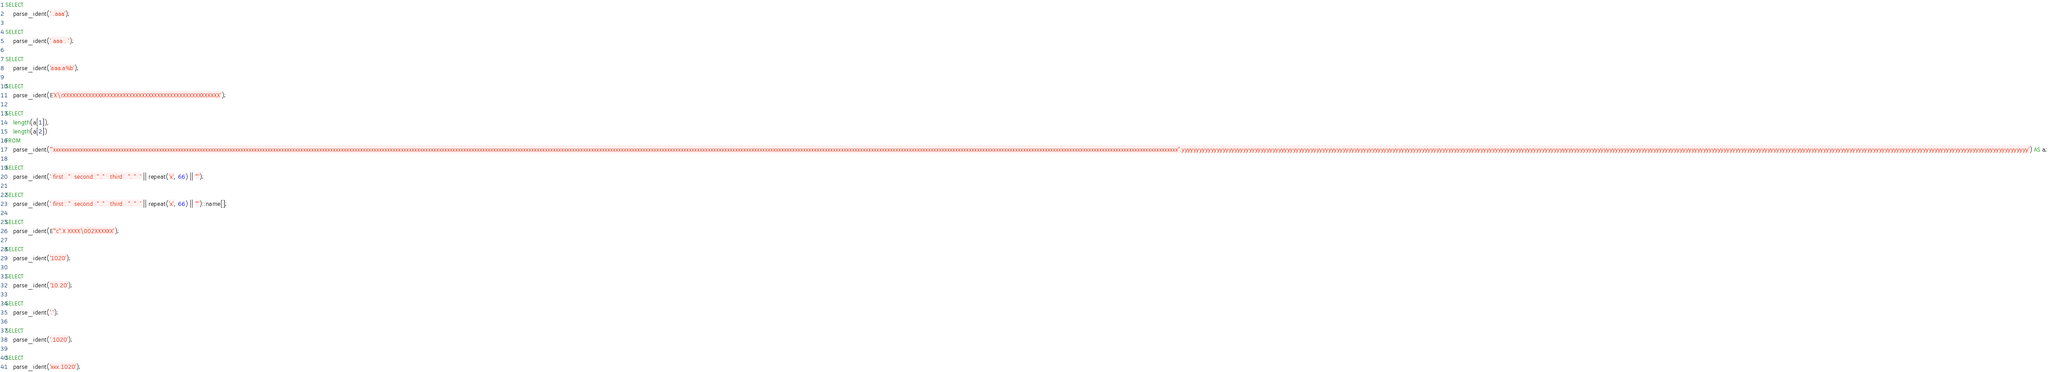<code> <loc_0><loc_0><loc_500><loc_500><_SQL_>SELECT
    parse_ident(' .aaa');

SELECT
    parse_ident(' aaa . ');

SELECT
    parse_ident('aaa.a%b');

SELECT
    parse_ident(E'X\rXXXXXXXXXXXXXXXXXXXXXXXXXXXXXXXXXXXXXXXXXXXXXXXXXX');

SELECT
    length(a[1]),
    length(a[2])
FROM
    parse_ident('"xxxxxxxxxxxxxxxxxxxxxxxxxxxxxxxxxxxxxxxxxxxxxxxxxxxxxxxxxxxxxxxxxxxxxxxxxxxxxxxxxxxxxxxxxxxxxxxxxxxxxxxxxxxxxxxxxxxxxxxxxxxxxxxxxxxxxxxxxxxxxxxxxxxxxxxxxxxxxxxxxxxxxxxxxxxxxxxxxxxxxxxxxxxxxxxxxxxxxxxxxxxxxxxxxxxxxxxxxxxxxxxxxxxxxxxxxxxxxxxxxxxxxxxxxxxxxxxxxxxxxxxxxxxxxxxxxxxxxxxxxxxxxxxxxxxxxxxxxxxxxxxxxxxxxxxxxxxxxxxxxxxxxxxxxxxxxxxxxxxxxxxxxxxxxxxxxxxxxxxxxxxxxxxxxxxxxxxxxxxxxxxxxxxxxxxxxxxxxxxxxxxxxxxxxxxxxx".yyyyyyyyyyyyyyyyyyyyyyyyyyyyyyyyyyyyyyyyyyyyyyyyyyyyyyyyyyyyyyyyyyyyyyyyyyyyyyyyyyyyyyyyyyyyyyyyyyyyyyyyyyyyyyyyyyyyyyyyyyyyyyyyyyyyyyyyyyyyyyyyyyyyyyyyyyyyyyyyyyyyyyyyyyyyyyyyyyyyyyyyyyyyyyyyyyyyyyyyyyyyyyyyyyyyyyyyyyyyyyyyyyyyyyyyyyyyyyyyyyyyyyyyyyyyyyyyyyyyyyyyyyyyyyyyyyyyyyyyyyyyyyyyy') AS a;

SELECT
    parse_ident(' first . "  second  " ."   third   ". "  ' || repeat('x', 66) || '"');

SELECT
    parse_ident(' first . "  second  " ."   third   ". "  ' || repeat('x', 66) || '"')::name[];

SELECT
    parse_ident(E'"c".X XXXX\002XXXXXX');

SELECT
    parse_ident('1020');

SELECT
    parse_ident('10.20');

SELECT
    parse_ident('.');

SELECT
    parse_ident('.1020');

SELECT
    parse_ident('xxx.1020');

</code> 